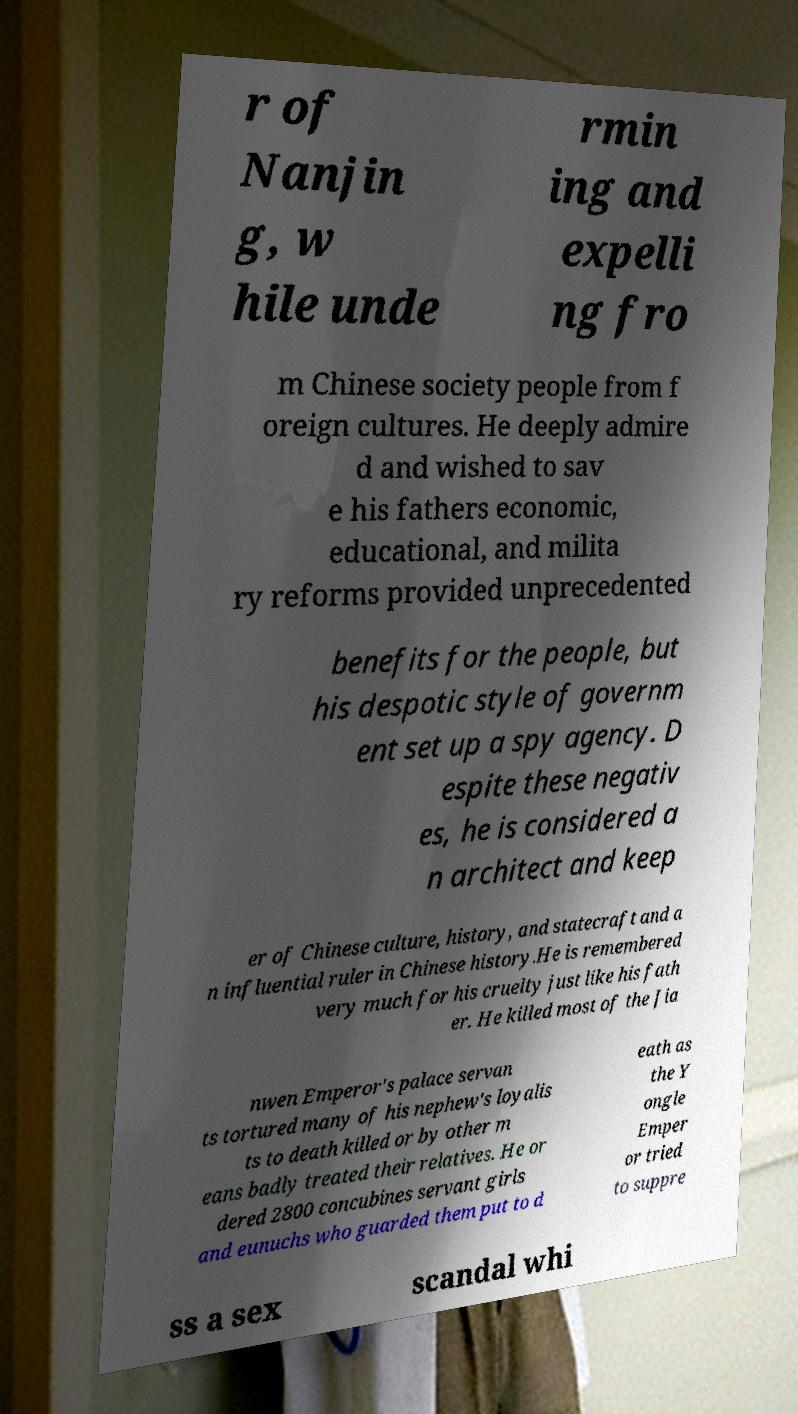I need the written content from this picture converted into text. Can you do that? r of Nanjin g, w hile unde rmin ing and expelli ng fro m Chinese society people from f oreign cultures. He deeply admire d and wished to sav e his fathers economic, educational, and milita ry reforms provided unprecedented benefits for the people, but his despotic style of governm ent set up a spy agency. D espite these negativ es, he is considered a n architect and keep er of Chinese culture, history, and statecraft and a n influential ruler in Chinese history.He is remembered very much for his cruelty just like his fath er. He killed most of the Jia nwen Emperor's palace servan ts tortured many of his nephew's loyalis ts to death killed or by other m eans badly treated their relatives. He or dered 2800 concubines servant girls and eunuchs who guarded them put to d eath as the Y ongle Emper or tried to suppre ss a sex scandal whi 